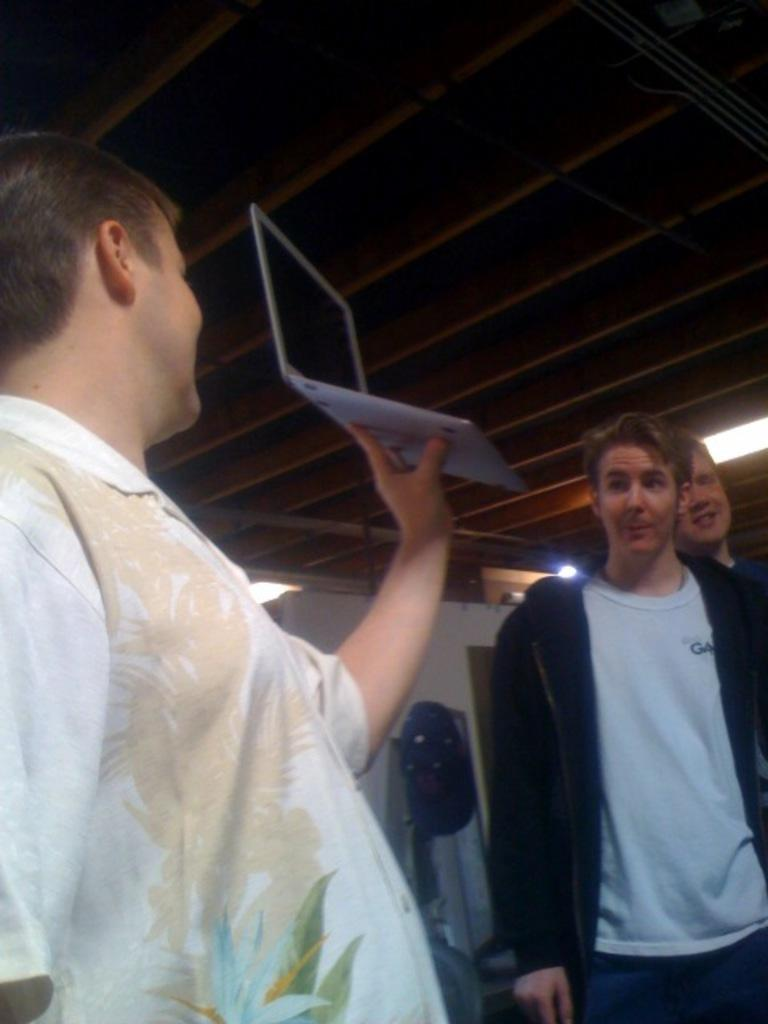How many people are in the image? There are people in the image, but the exact number is not specified. What is one person doing in the image? One person is holding a laptop in the image. What type of structure is visible in the image? There is a roof visible in the image, which suggests a building or shelter. What can be seen on the wall in the image? There is a wall with objects in the image, but the specific objects are not described. How does the person with the laptop ensure their comfort while using the device in the image? There is no information about the person's comfort or any adjustments they might be making while using the laptop in the image. 